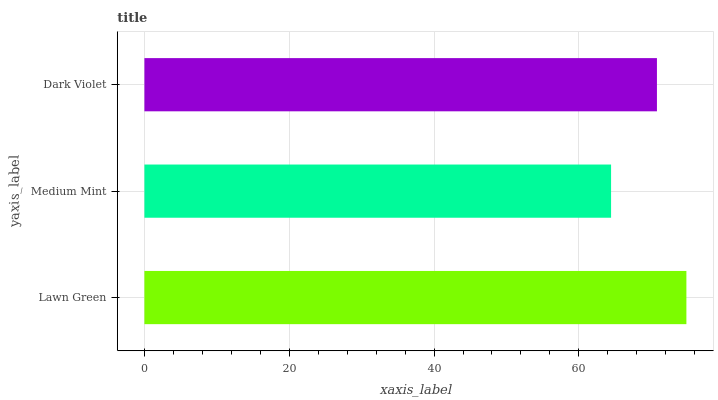Is Medium Mint the minimum?
Answer yes or no. Yes. Is Lawn Green the maximum?
Answer yes or no. Yes. Is Dark Violet the minimum?
Answer yes or no. No. Is Dark Violet the maximum?
Answer yes or no. No. Is Dark Violet greater than Medium Mint?
Answer yes or no. Yes. Is Medium Mint less than Dark Violet?
Answer yes or no. Yes. Is Medium Mint greater than Dark Violet?
Answer yes or no. No. Is Dark Violet less than Medium Mint?
Answer yes or no. No. Is Dark Violet the high median?
Answer yes or no. Yes. Is Dark Violet the low median?
Answer yes or no. Yes. Is Lawn Green the high median?
Answer yes or no. No. Is Lawn Green the low median?
Answer yes or no. No. 